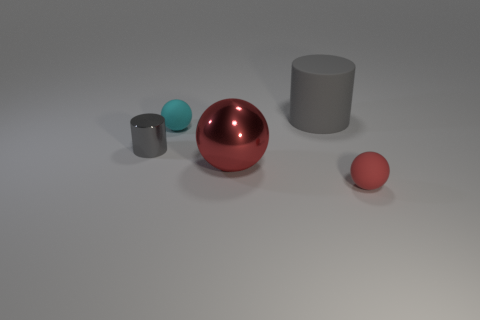What material is the big gray cylinder? While I can't determine the exact material from a picture alone, the big gray cylinder appears to have a matte finish, which is commonly seen in plastics or painted metals used for industrial or household objects. 